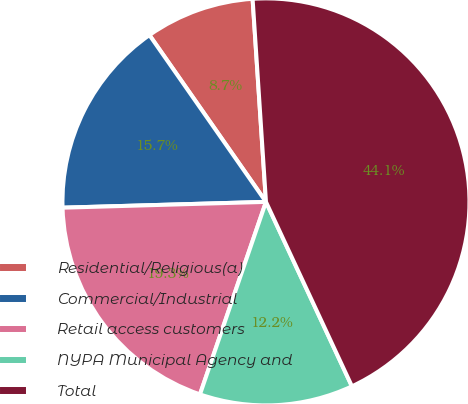<chart> <loc_0><loc_0><loc_500><loc_500><pie_chart><fcel>Residential/Religious(a)<fcel>Commercial/Industrial<fcel>Retail access customers<fcel>NYPA Municipal Agency and<fcel>Total<nl><fcel>8.66%<fcel>15.75%<fcel>19.29%<fcel>12.2%<fcel>44.11%<nl></chart> 